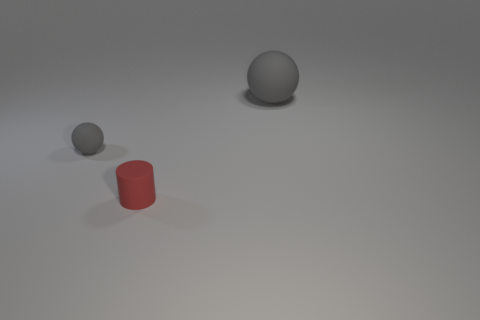Subtract all yellow cylinders. Subtract all cyan balls. How many cylinders are left? 1 Add 3 yellow matte spheres. How many objects exist? 6 Subtract all balls. How many objects are left? 1 Add 3 yellow metallic objects. How many yellow metallic objects exist? 3 Subtract 0 purple cubes. How many objects are left? 3 Subtract all big gray balls. Subtract all gray matte objects. How many objects are left? 0 Add 1 tiny red objects. How many tiny red objects are left? 2 